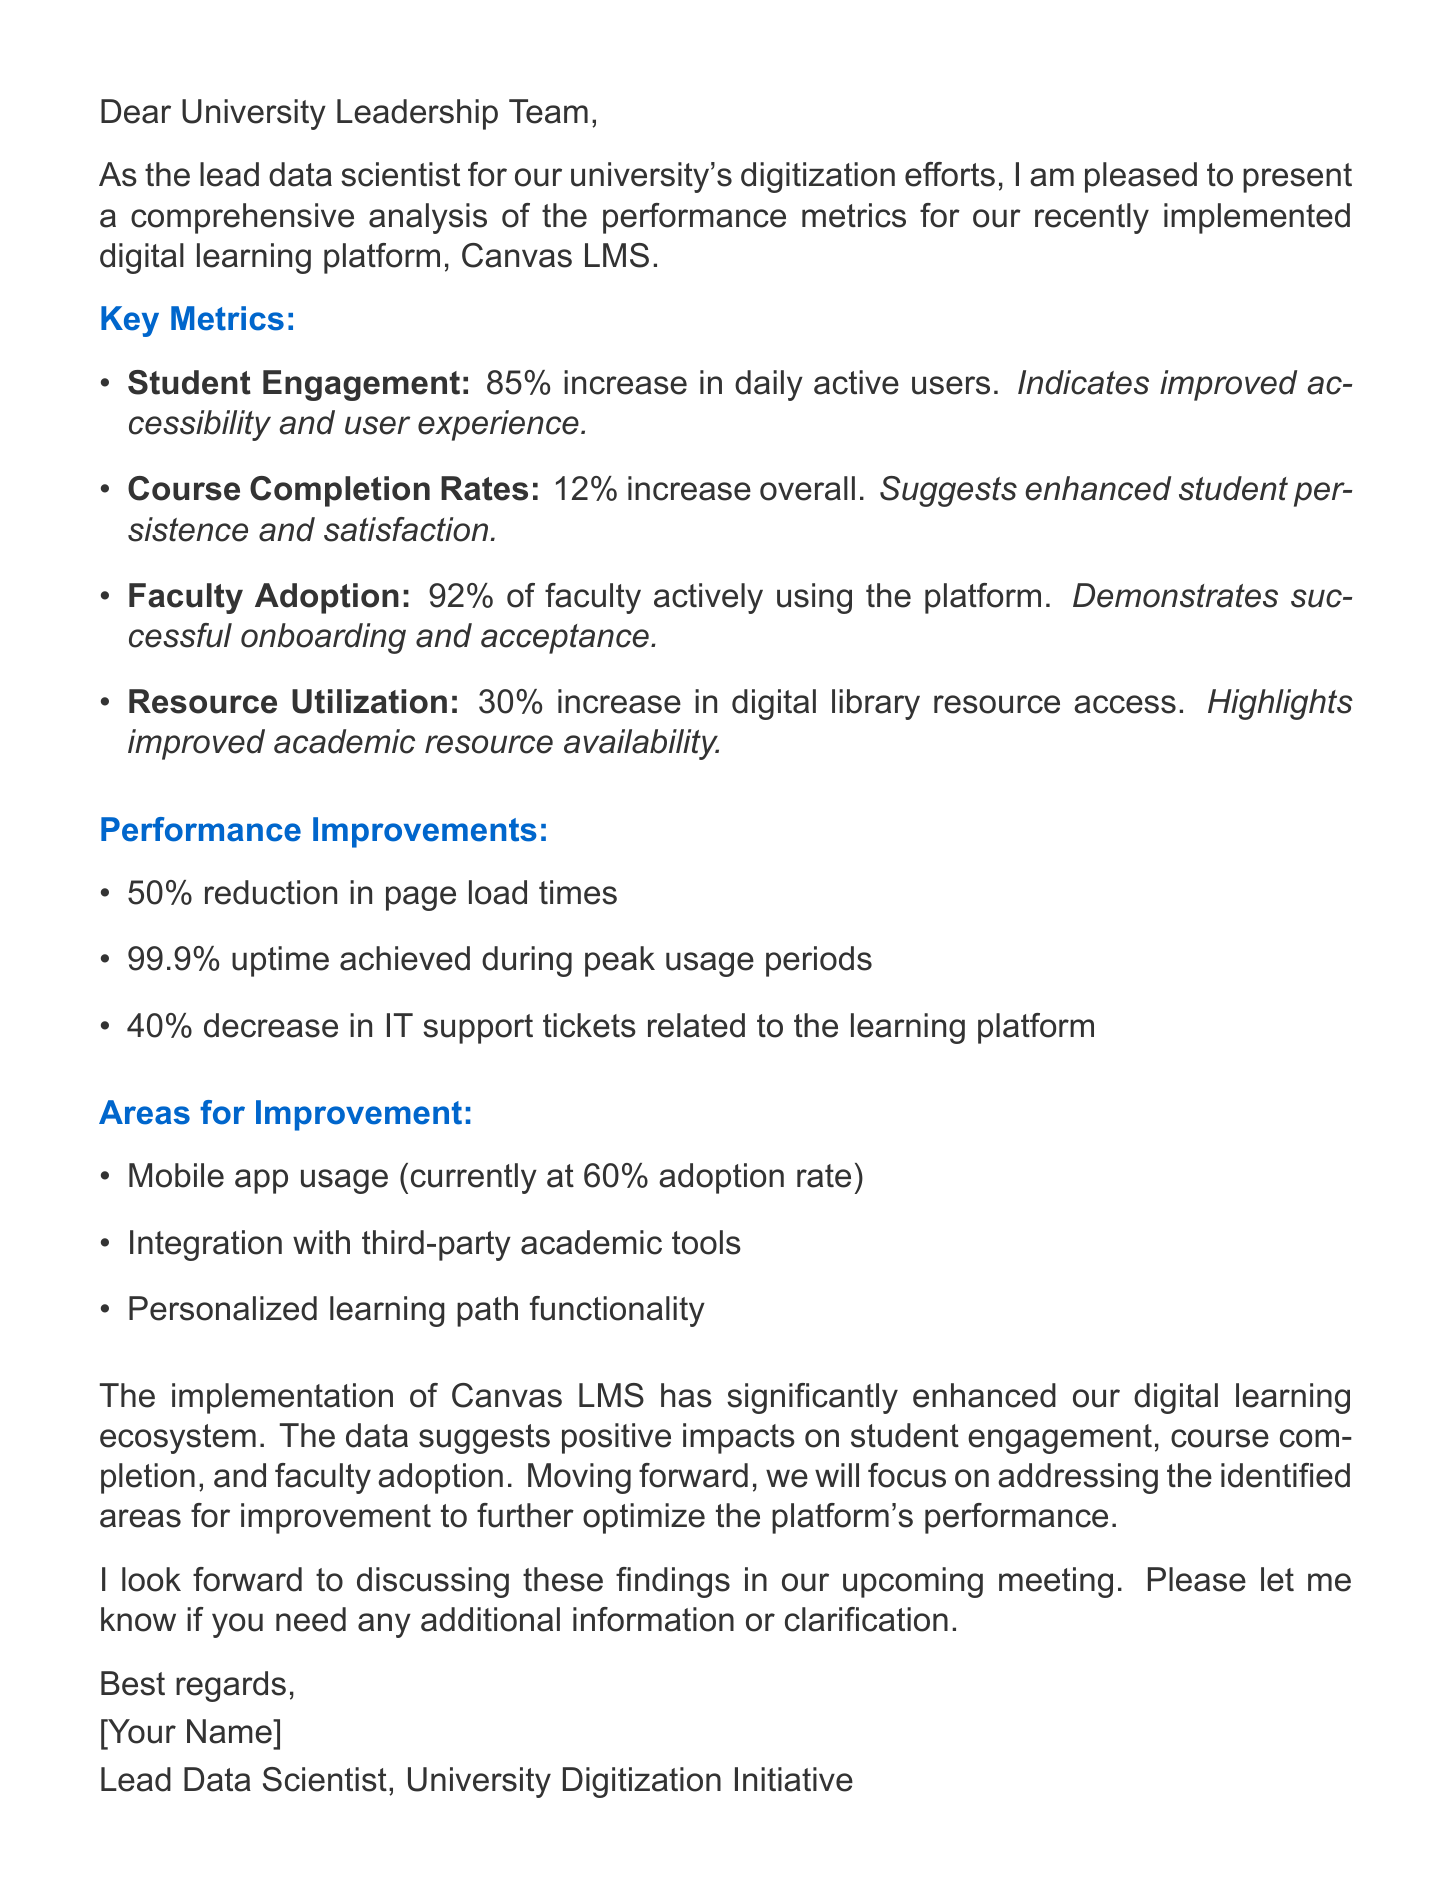What is the increase in daily active users? The document states there is an 85% increase in daily active users compared to the previous system.
Answer: 85% What percentage of faculty members are actively using the platform? The document mentions that 92% of faculty members are actively using the platform within the first semester.
Answer: 92% What is the course completion rate increase? According to the document, there is a 12% increase in overall course completion rates.
Answer: 12% How much did IT support tickets decrease? The report indicates a 40% decrease in IT support tickets related to the learning platform.
Answer: 40% What is the current adoption rate of the mobile app? The document states that the mobile app usage is currently at a 60% adoption rate.
Answer: 60% What is one insight regarding student engagement? The report notes that a high increase indicates improved accessibility and user experience.
Answer: Improved accessibility and user experience Which performance improvement had the highest percentage? The report indicates a 50% reduction in page load times as the highest percentage performance improvement.
Answer: 50% What are the areas identified for improvement? The document lists mobile app usage, integration with third-party tools, and personalized learning paths.
Answer: Mobile app usage, integration with third-party academic tools, personalized learning path functionality What is the overall conclusion of the report? The conclusion states that the implementation of Canvas LMS has significantly enhanced the digital learning ecosystem.
Answer: Significantly enhanced our digital learning ecosystem 